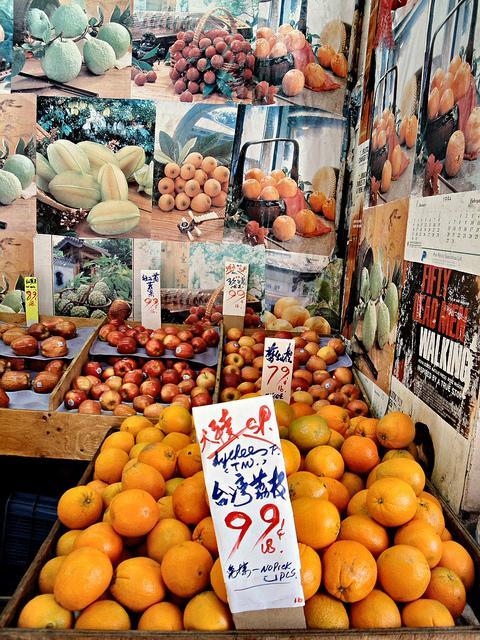How much would 2 pounds of oranges cost? Please explain your reasoning. 1.98. Two multiplied by 99 is 198. 